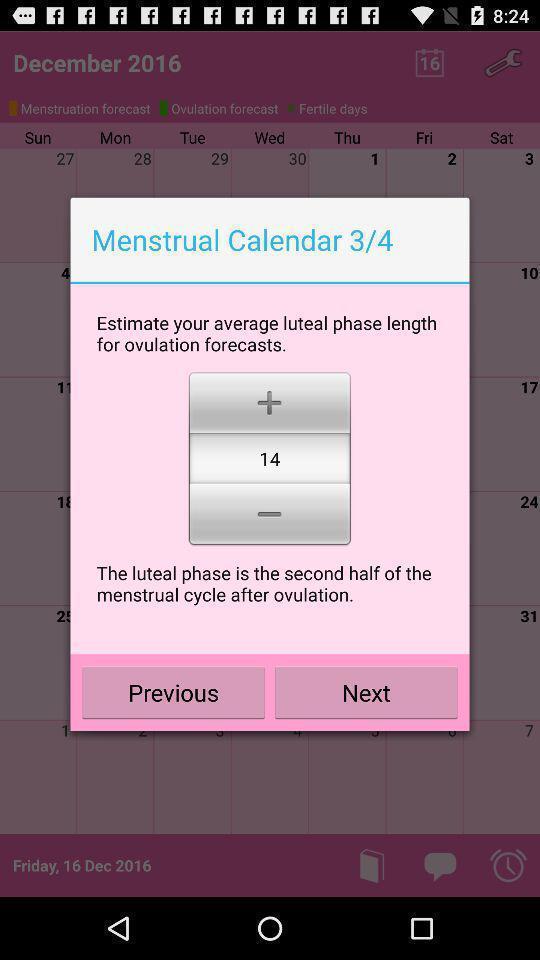Provide a textual representation of this image. Pop-up for set up menstrual calendar options on calendar app. 